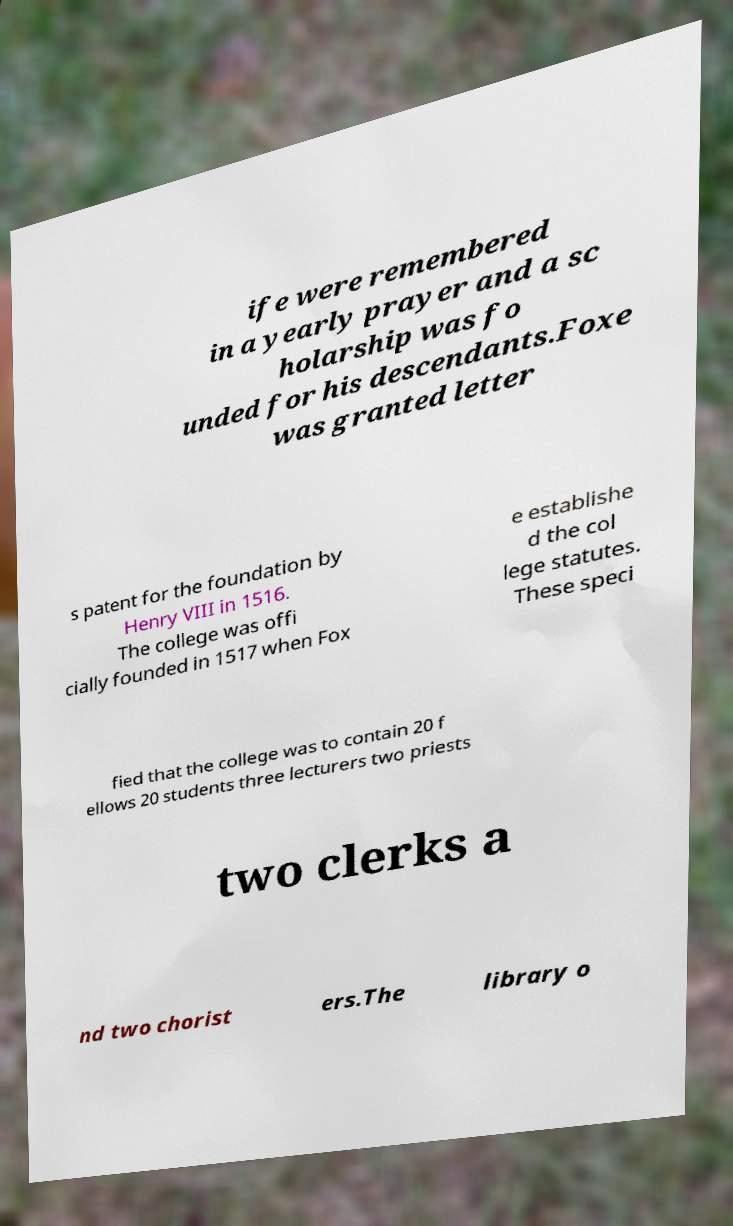Could you assist in decoding the text presented in this image and type it out clearly? ife were remembered in a yearly prayer and a sc holarship was fo unded for his descendants.Foxe was granted letter s patent for the foundation by Henry VIII in 1516. The college was offi cially founded in 1517 when Fox e establishe d the col lege statutes. These speci fied that the college was to contain 20 f ellows 20 students three lecturers two priests two clerks a nd two chorist ers.The library o 